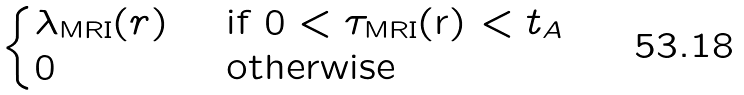<formula> <loc_0><loc_0><loc_500><loc_500>\begin{cases} \lambda _ { \text {MRI} } ( r ) & \text { if   $0< \tau_{\text {MRI}}$(r) $< t_{A}$} \\ 0 & \text { otherwise} \end{cases}</formula> 